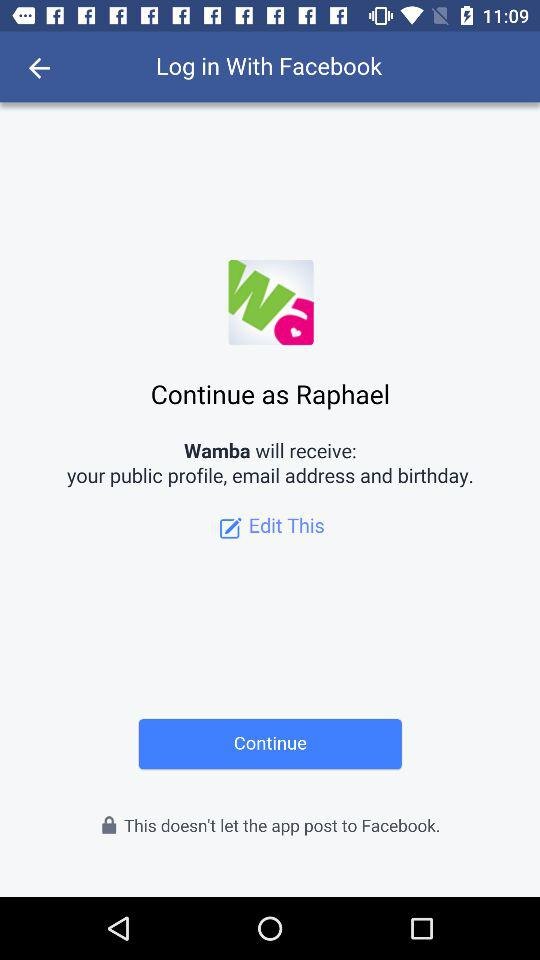Who will receive my public profile, email address, and birthday? Your public profile, email address, and birthday will be received by "Wamba". 